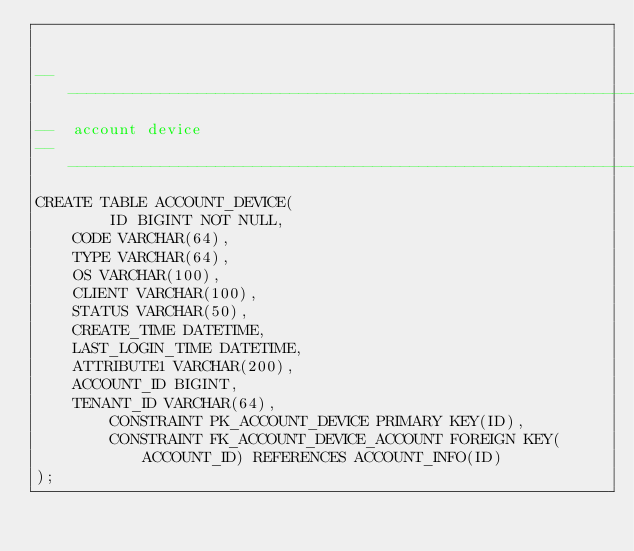<code> <loc_0><loc_0><loc_500><loc_500><_SQL_>

-------------------------------------------------------------------------------
--  account device
-------------------------------------------------------------------------------
CREATE TABLE ACCOUNT_DEVICE(
        ID BIGINT NOT NULL,
	CODE VARCHAR(64),
	TYPE VARCHAR(64),
	OS VARCHAR(100),
	CLIENT VARCHAR(100),
	STATUS VARCHAR(50),
	CREATE_TIME DATETIME,
	LAST_LOGIN_TIME DATETIME,
	ATTRIBUTE1 VARCHAR(200),
	ACCOUNT_ID BIGINT,
	TENANT_ID VARCHAR(64),
        CONSTRAINT PK_ACCOUNT_DEVICE PRIMARY KEY(ID),
        CONSTRAINT FK_ACCOUNT_DEVICE_ACCOUNT FOREIGN KEY(ACCOUNT_ID) REFERENCES ACCOUNT_INFO(ID)
);

</code> 